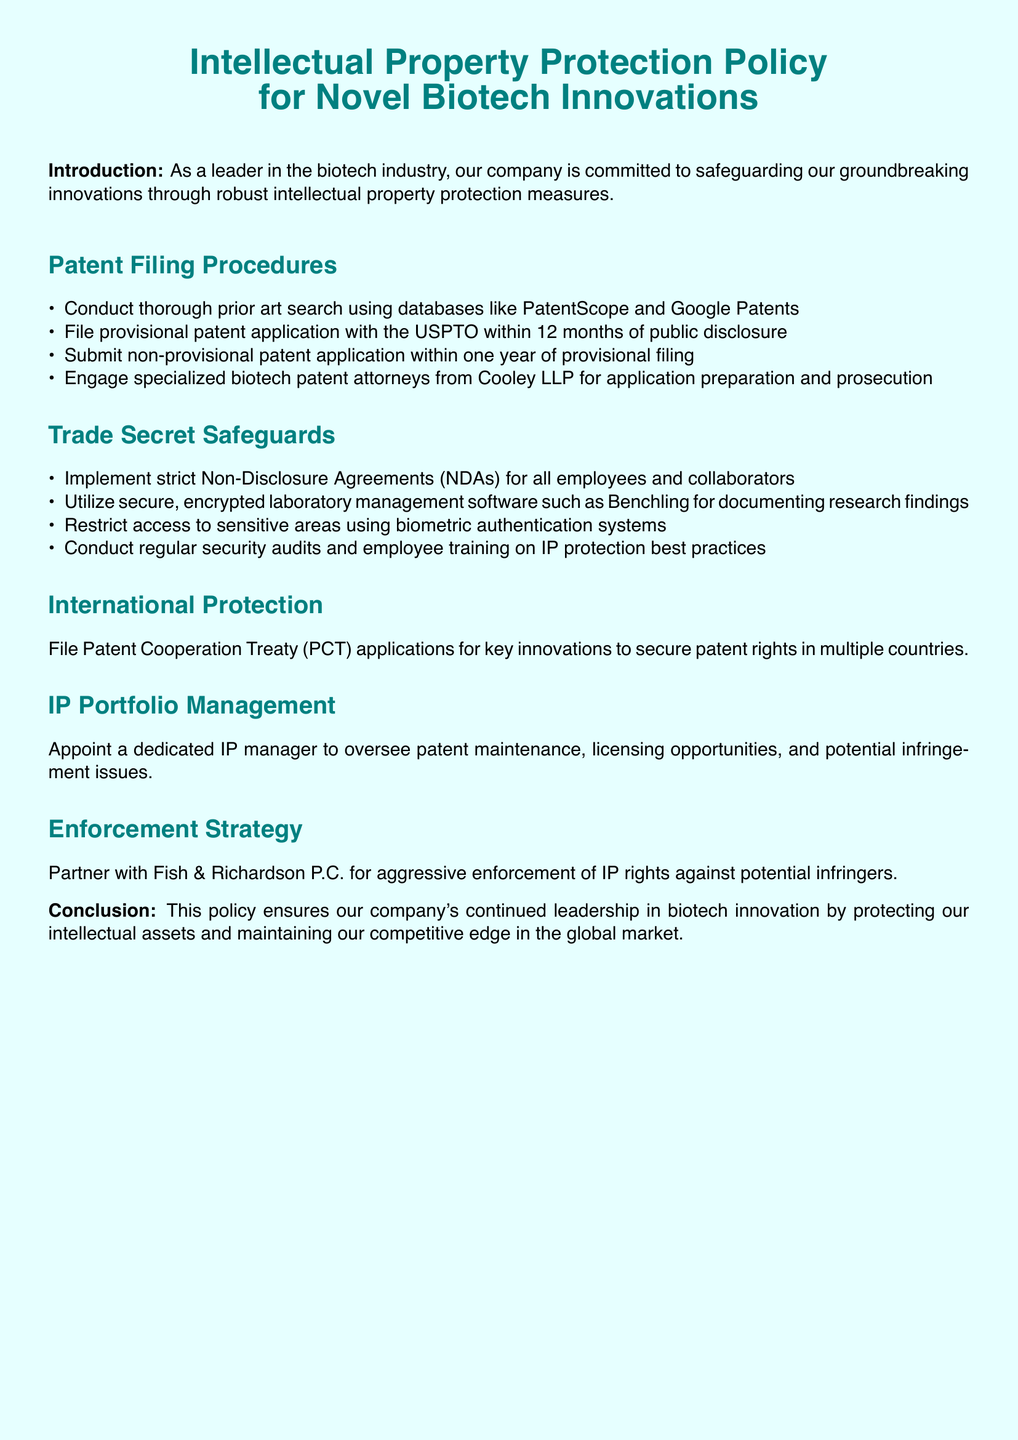What is the document about? The document outlines the intellectual property protection policy specifically for novel biotech innovations within the company.
Answer: Intellectual Property Protection Policy for Novel Biotech Innovations How long do you have to file a provisional patent application after public disclosure? The document states that one must file the provisional patent application within 12 months of public disclosure.
Answer: 12 months What is the specialized law firm mentioned for patent application preparation? The document names Cooley LLP as the specialized biotech patent attorneys for application preparation and prosecution.
Answer: Cooley LLP What is the purpose of the Non-Disclosure Agreements (NDAs)? The document indicates that NDAs are implemented for all employees and collaborators to safeguard trade secrets.
Answer: Safeguarding trade secrets What authority oversees patent maintenance and licensing opportunities? The document specifies that a dedicated IP manager is appointed to oversee these aspects.
Answer: IP manager What is the purpose of filing a Patent Cooperation Treaty (PCT) application? The purpose outlined in the document is to secure patent rights in multiple countries.
Answer: Secure patent rights in multiple countries Which company is partnered with for enforcement of IP rights? The document mentions that Fish & Richardson P.C. is the partner for aggressive enforcement of IP rights.
Answer: Fish & Richardson P.C What type of software is recommended for documenting research findings? The document recommends the use of secure, encrypted laboratory management software.
Answer: Benchling How often should security audits be conducted according to the policy? While it does not specify a frequency, the document mentions conducting regular security audits as part of trade secret safeguards.
Answer: Regularly 